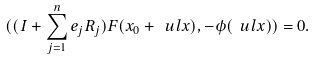<formula> <loc_0><loc_0><loc_500><loc_500>( ( I + \sum _ { j = 1 } ^ { n } e _ { j } R _ { j } ) F ( x _ { 0 } + \ u l x ) , - \phi ( \ u l x ) ) = 0 .</formula> 